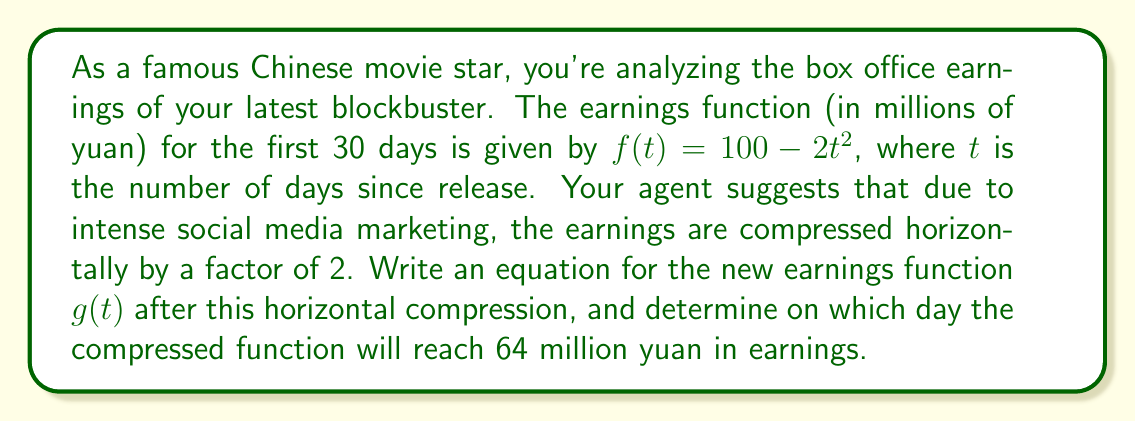Show me your answer to this math problem. To solve this problem, we'll follow these steps:

1) First, let's understand what horizontal compression by a factor of 2 means. It essentially squeezes the graph horizontally, making it reach the same y-values twice as fast. This is achieved by replacing $t$ with $2t$ in the original function.

2) The original function is $f(t) = 100 - 2t^2$. After horizontal compression, the new function $g(t)$ becomes:

   $g(t) = 100 - 2(2t)^2 = 100 - 2(4t^2) = 100 - 8t^2$

3) Now that we have the new function, we need to find when it equals 64 million yuan:

   $64 = 100 - 8t^2$

4) Subtract 100 from both sides:

   $-36 = -8t^2$

5) Divide both sides by -8:

   $4.5 = t^2$

6) Take the square root of both sides. Since we're dealing with time, we only consider the positive root:

   $t = \sqrt{4.5} \approx 2.12$

7) Round to the nearest whole number of days:

   $t \approx 2$ days

This means the compressed function will reach 64 million yuan in earnings on the 2nd day after release.
Answer: The new earnings function after horizontal compression is $g(t) = 100 - 8t^2$, and it will reach 64 million yuan in earnings on the 2nd day after release. 